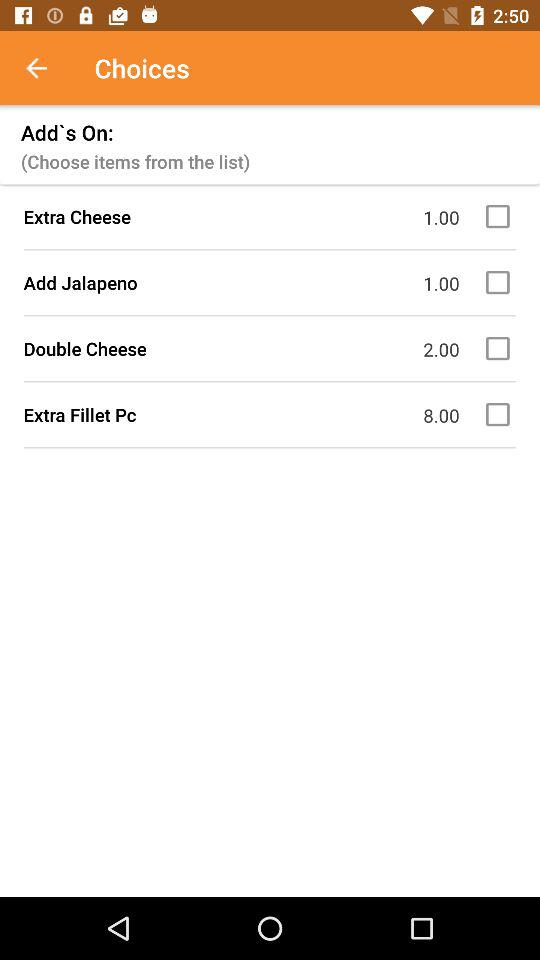What is the name of the item in "Add's On" whose price is 2.00? The item is "Double Cheese". 